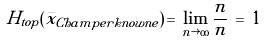Convert formula to latex. <formula><loc_0><loc_0><loc_500><loc_500>H _ { t o p } ( \bar { x } _ { C h a m p e r k n o w n e } ) \, = \, \lim _ { n \rightarrow \infty } \frac { n } { n } \, = \, 1</formula> 